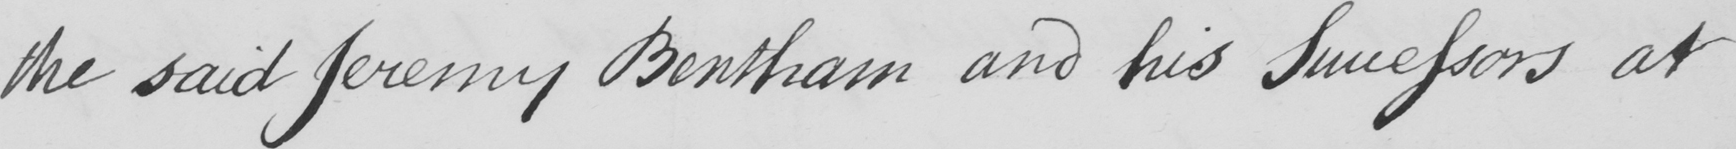Please provide the text content of this handwritten line. the said Jeremy Bentham and his Successors at 